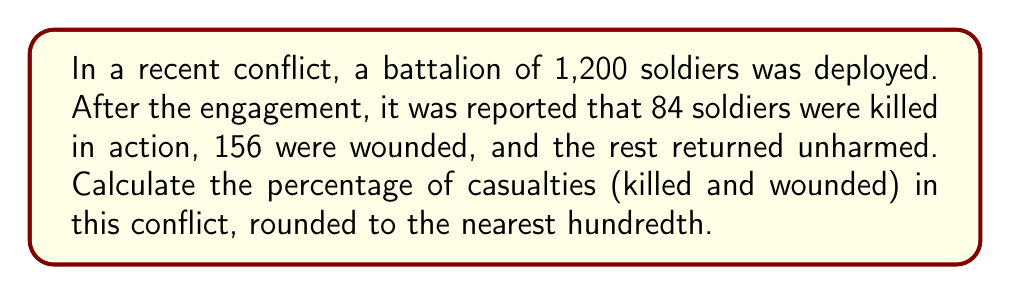Could you help me with this problem? To solve this problem, we'll follow these steps:

1. Calculate the total number of casualties:
   Casualties = Killed + Wounded
   $84 + 156 = 240$ casualties

2. Calculate the percentage of casualties:
   Percentage = (Number of casualties / Total number of soldiers) × 100

   $$\text{Percentage} = \frac{\text{Casualties}}{\text{Total soldiers}} \times 100$$

   $$\text{Percentage} = \frac{240}{1200} \times 100$$

3. Simplify the fraction:
   $$\frac{240}{1200} = \frac{1}{5} = 0.2$$

4. Multiply by 100:
   $$0.2 \times 100 = 20$$

5. Round to the nearest hundredth (which is already done in this case):
   20.00%

Therefore, the percentage of casualties in this conflict is 20.00%.
Answer: 20.00% 